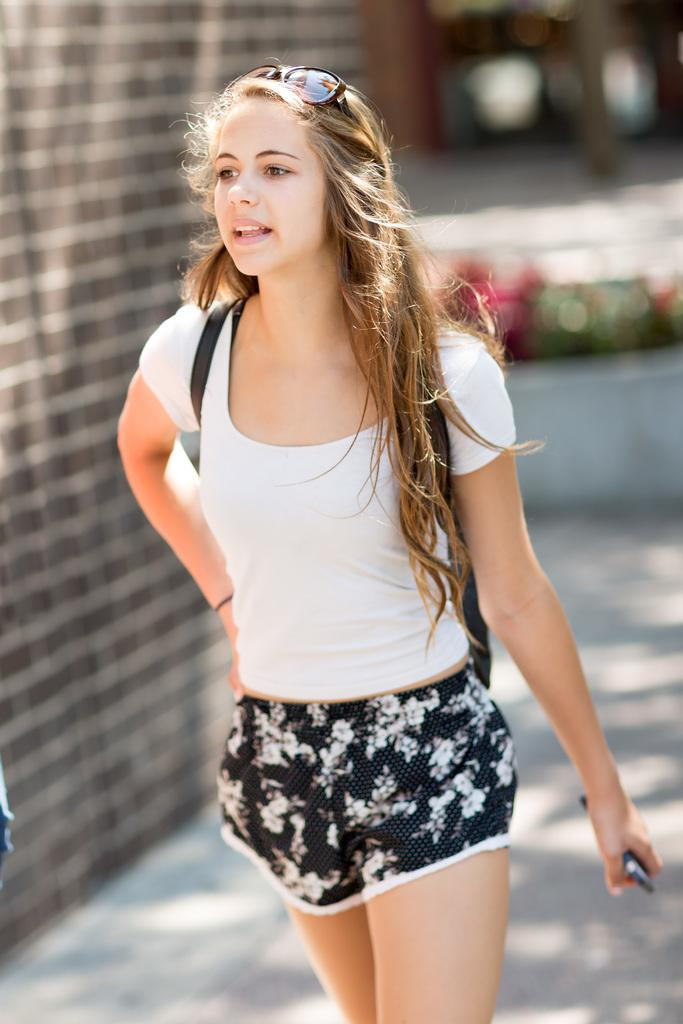What is the woman in the image wearing on her upper body? The woman is wearing a T-shirt. What is the woman wearing on her lower body? The woman is wearing shorts. What type of eyewear is the woman wearing in the image? The woman is wearing goggles. What is the woman holding in her hand? The woman is holding an object in her hand. What can be seen in the background of the image? The background appears blurry. What type of dress is the doctor wearing in the image? There is no doctor or dress present in the image. 